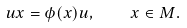Convert formula to latex. <formula><loc_0><loc_0><loc_500><loc_500>u x = \phi ( x ) u , \quad x \in M .</formula> 